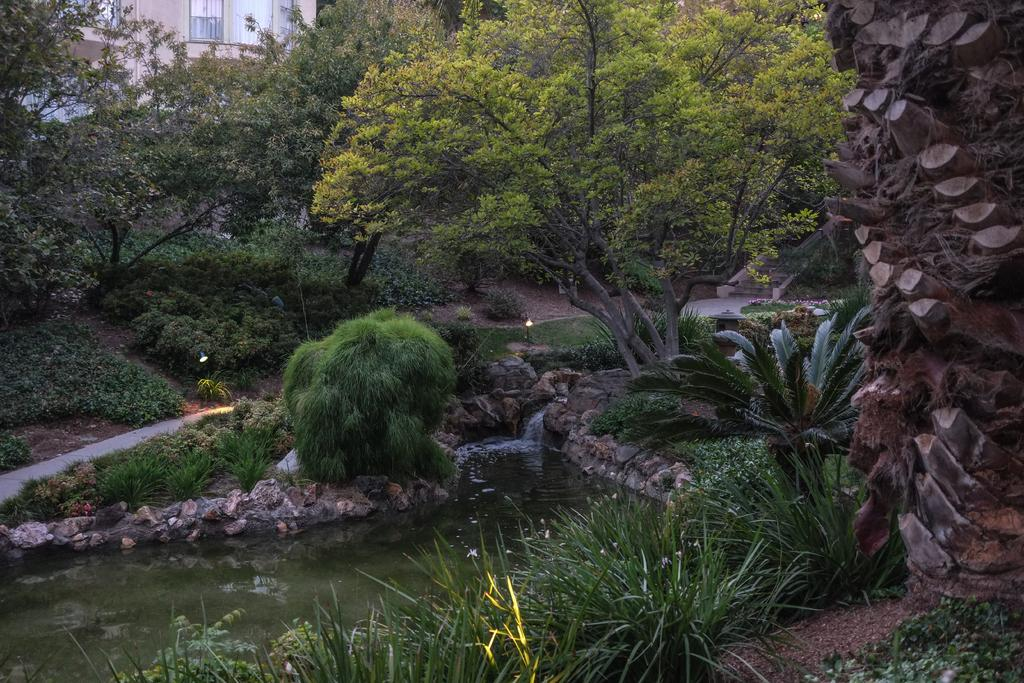What type of natural elements can be seen in the image? There are trees and plants in the image. What type of man-made structures are visible in the image? There are stores and a building in the image. What is the water feature in the image? There is water visible in the image. How many sisters does the father have in the image? There is no father or sisters present in the image. What angle is the building leaning at in the image? The building is not leaning in the image; it is standing upright. 